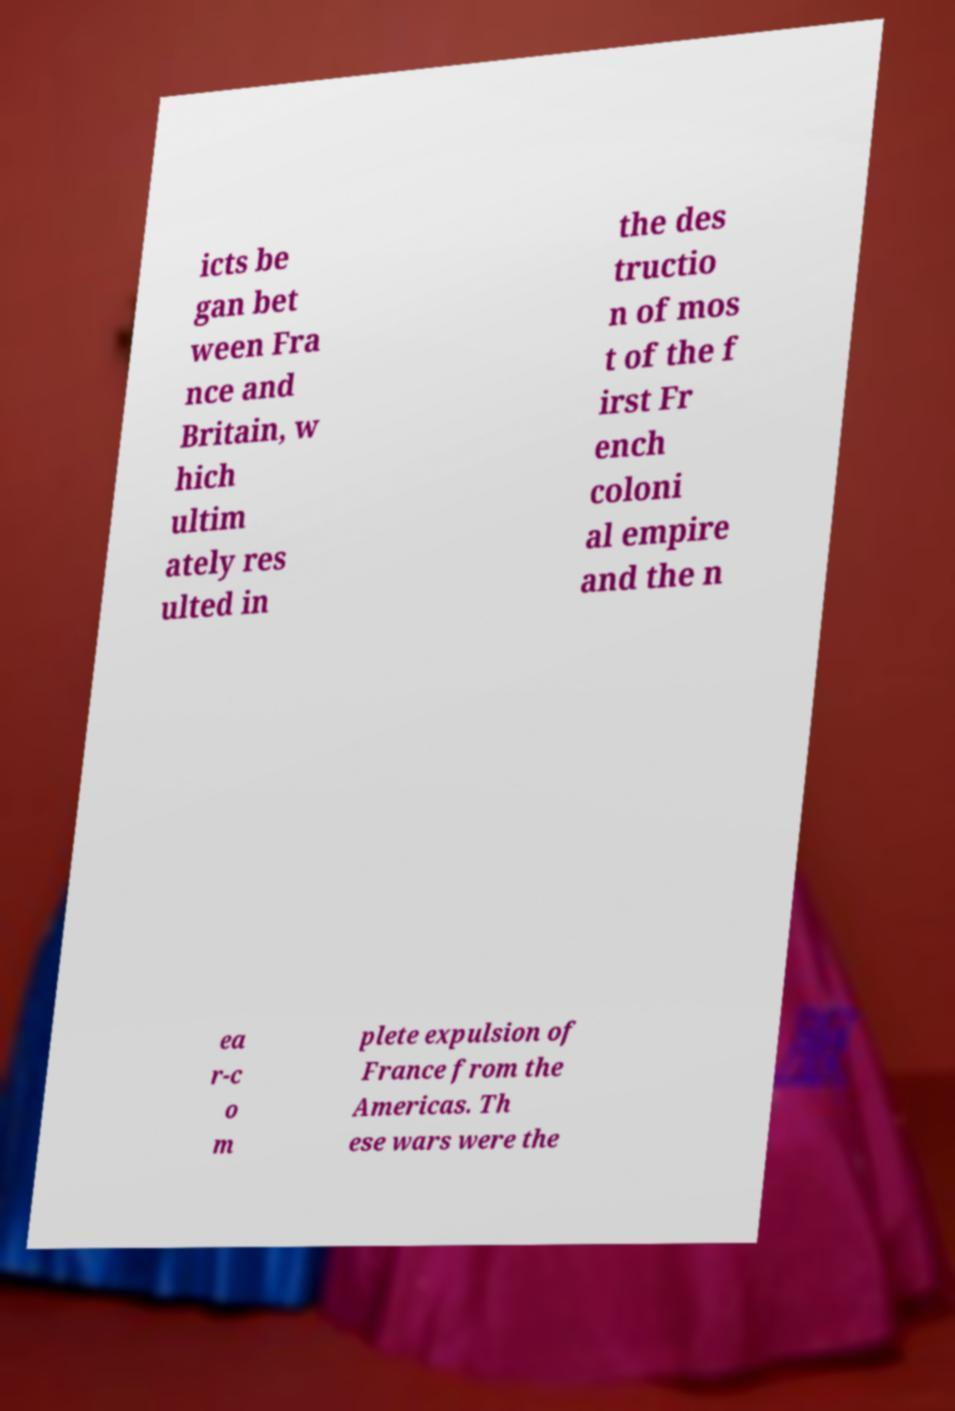For documentation purposes, I need the text within this image transcribed. Could you provide that? icts be gan bet ween Fra nce and Britain, w hich ultim ately res ulted in the des tructio n of mos t of the f irst Fr ench coloni al empire and the n ea r-c o m plete expulsion of France from the Americas. Th ese wars were the 